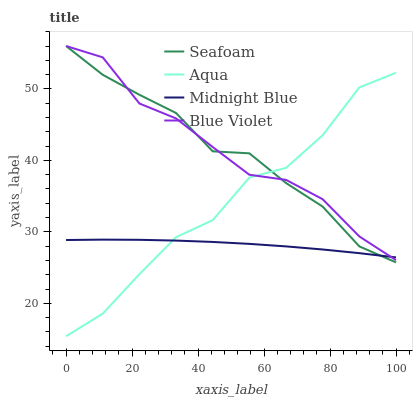Does Midnight Blue have the minimum area under the curve?
Answer yes or no. Yes. Does Blue Violet have the maximum area under the curve?
Answer yes or no. Yes. Does Seafoam have the minimum area under the curve?
Answer yes or no. No. Does Seafoam have the maximum area under the curve?
Answer yes or no. No. Is Midnight Blue the smoothest?
Answer yes or no. Yes. Is Aqua the roughest?
Answer yes or no. Yes. Is Seafoam the smoothest?
Answer yes or no. No. Is Seafoam the roughest?
Answer yes or no. No. Does Aqua have the lowest value?
Answer yes or no. Yes. Does Seafoam have the lowest value?
Answer yes or no. No. Does Blue Violet have the highest value?
Answer yes or no. Yes. Does Midnight Blue have the highest value?
Answer yes or no. No. Does Midnight Blue intersect Blue Violet?
Answer yes or no. Yes. Is Midnight Blue less than Blue Violet?
Answer yes or no. No. Is Midnight Blue greater than Blue Violet?
Answer yes or no. No. 